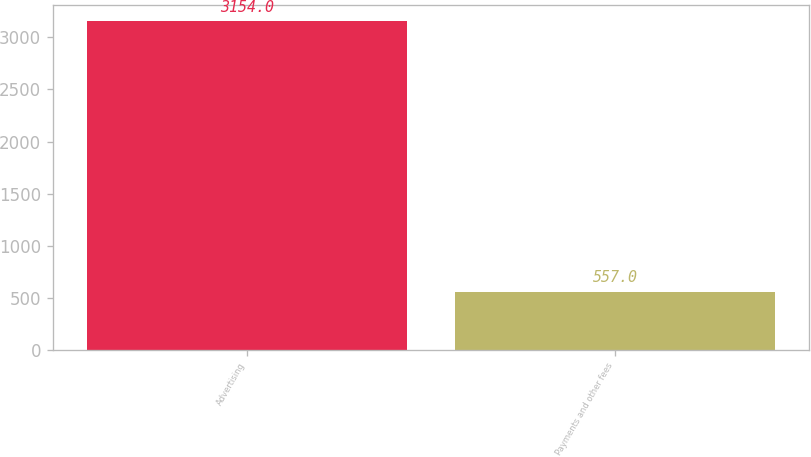Convert chart to OTSL. <chart><loc_0><loc_0><loc_500><loc_500><bar_chart><fcel>Advertising<fcel>Payments and other fees<nl><fcel>3154<fcel>557<nl></chart> 